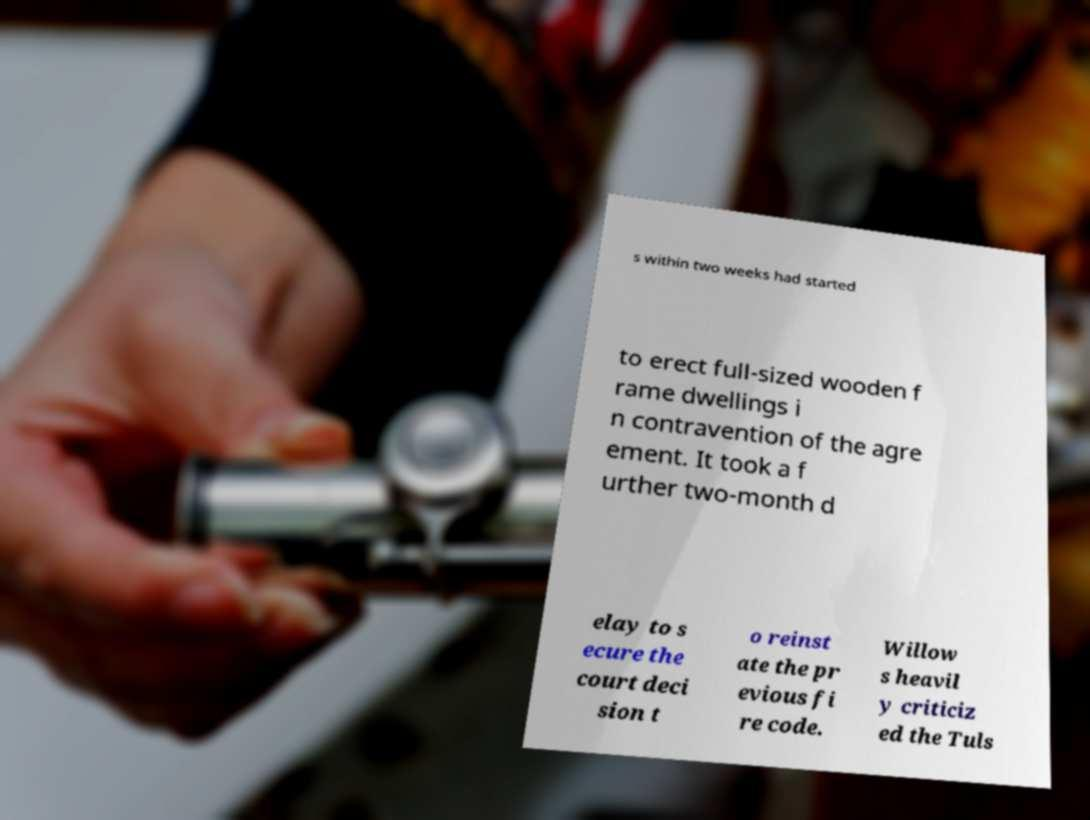What messages or text are displayed in this image? I need them in a readable, typed format. s within two weeks had started to erect full-sized wooden f rame dwellings i n contravention of the agre ement. It took a f urther two-month d elay to s ecure the court deci sion t o reinst ate the pr evious fi re code. Willow s heavil y criticiz ed the Tuls 